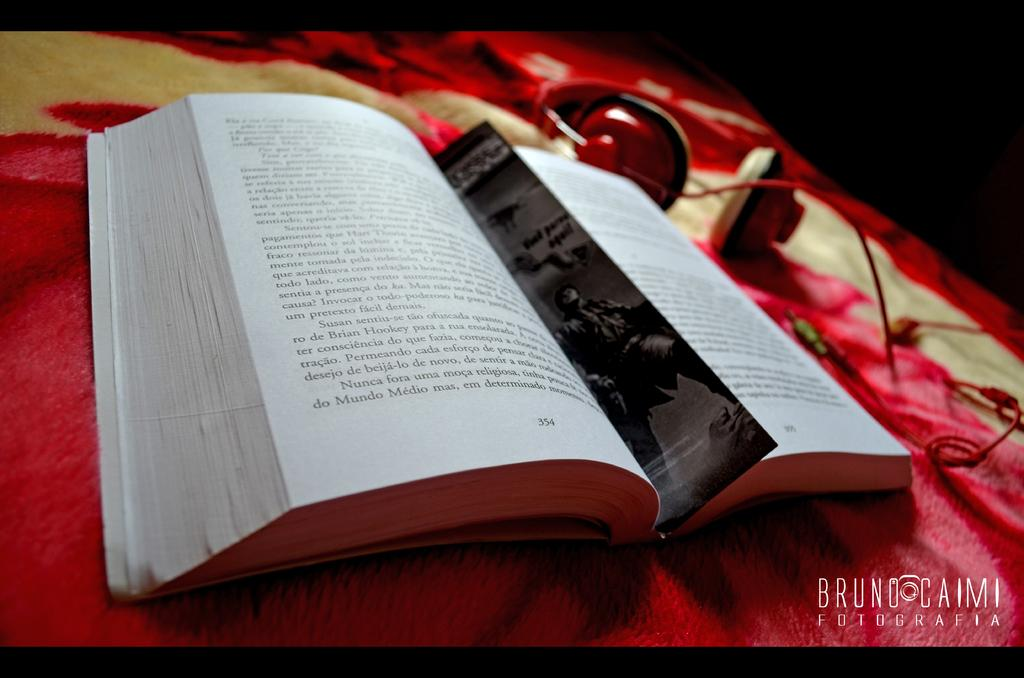<image>
Present a compact description of the photo's key features. The water mark on a photo identifies the photographer ad Bruno Caimi. 